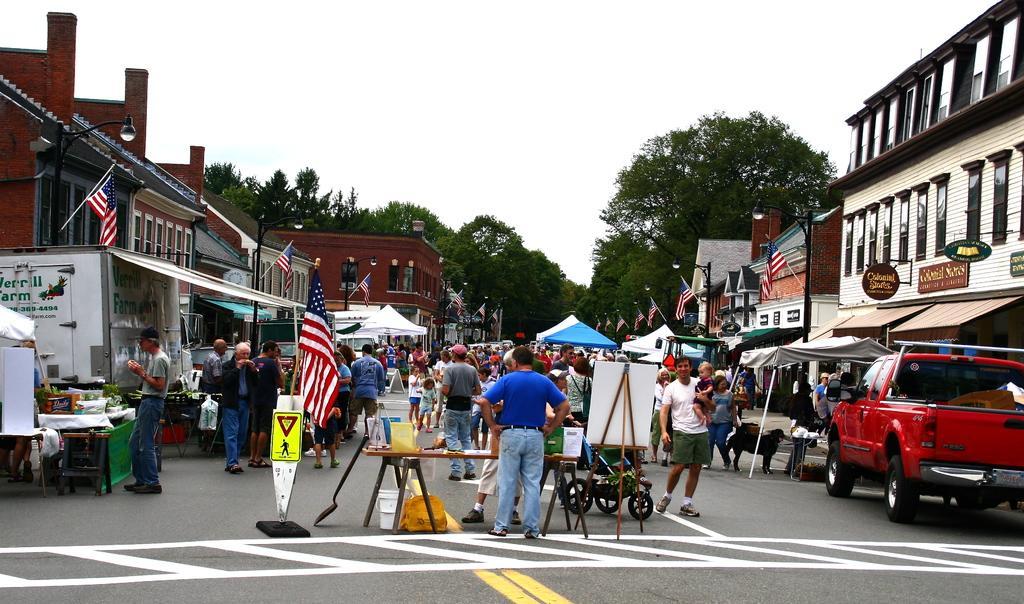Could you give a brief overview of what you see in this image? In this picture we can see some people are standing and some people are walking on the road and a person is holding a stroller. A man in the blue t shirt is standing and in front of the man there is a table and on the table there are some objects. On the right side of the man there is a stand with board, a vehicle and a dog and buildings with name boards. On the left side of the people there are vehicles, flags with sticks and poles with lights. Behind the people there are stalls, buildings, trees and the sky. 